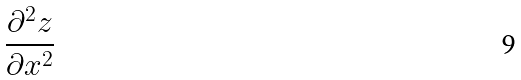Convert formula to latex. <formula><loc_0><loc_0><loc_500><loc_500>\frac { \partial ^ { 2 } z } { \partial x ^ { 2 } }</formula> 